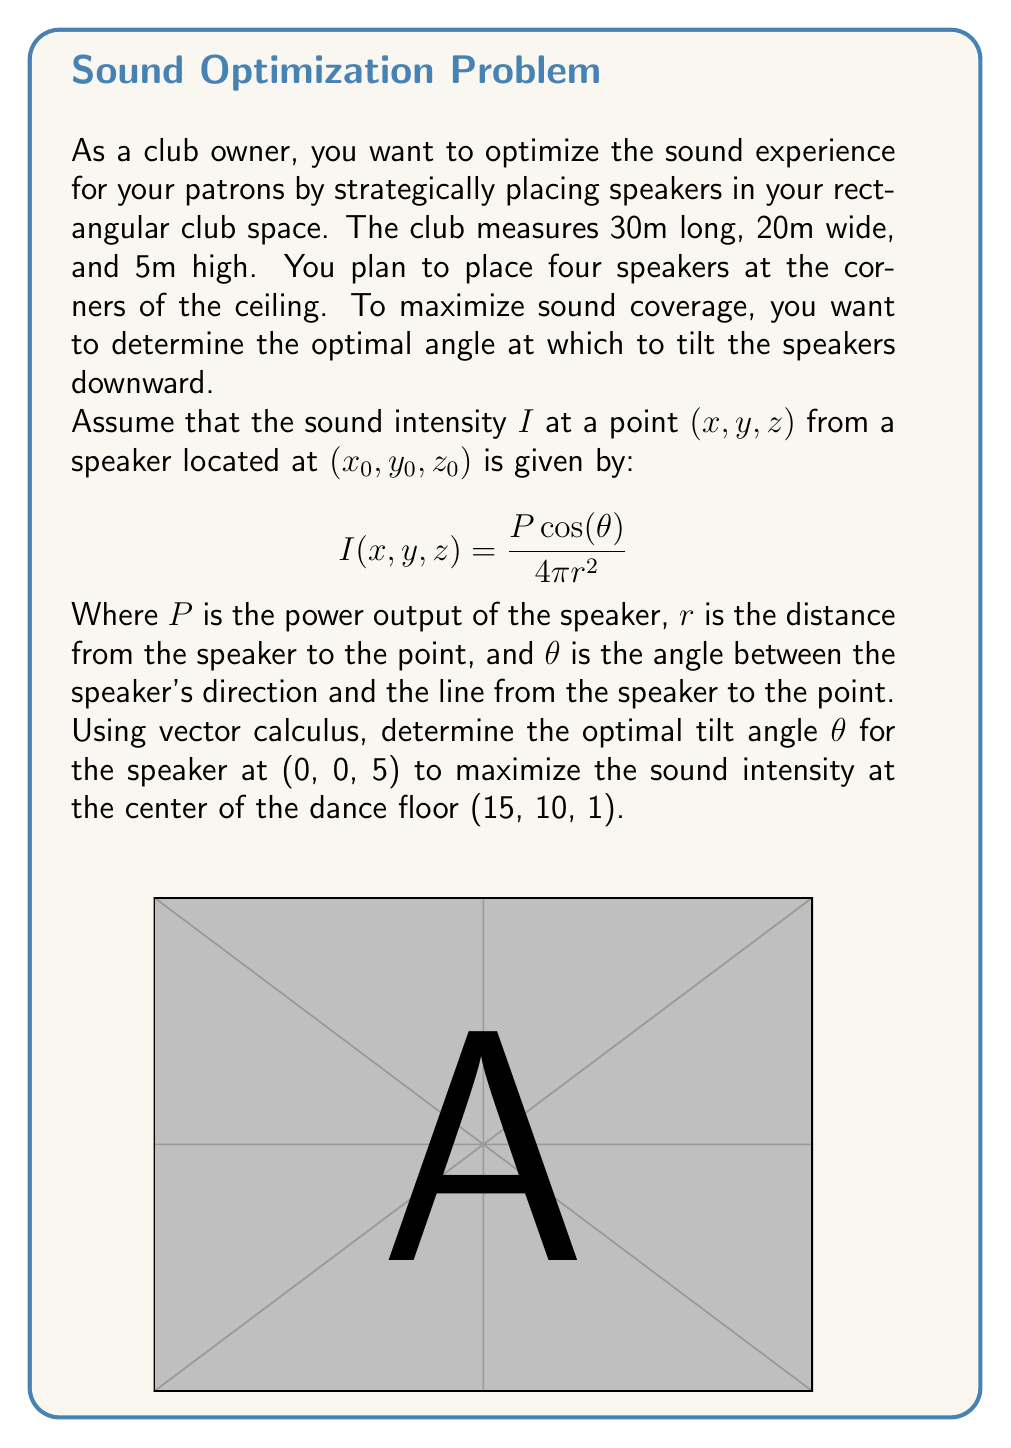Show me your answer to this math problem. Let's approach this step-by-step:

1) First, we need to find the vector from the speaker to the center of the dance floor:
   $\vec{v} = (15, 10, -4)$

2) The magnitude of this vector (distance $r$) is:
   $r = \sqrt{15^2 + 10^2 + (-4)^2} = \sqrt{425} \approx 20.616$ m

3) The unit vector in the direction of $\vec{v}$ is:
   $\hat{v} = (\frac{15}{\sqrt{425}}, \frac{10}{\sqrt{425}}, \frac{-4}{\sqrt{425}})$

4) The speaker's direction vector when tilted at an angle $\theta$ from the vertical is:
   $\vec{d} = (0, 0, -1)$ when $\theta = 0$, and $(sin\theta, 0, -cos\theta)$ in general.

5) The cosine of the angle between $\vec{d}$ and $\vec{v}$ is their dot product:
   $cos(\alpha) = \vec{d} \cdot \hat{v} = sin\theta \cdot \frac{15}{\sqrt{425}} + 0 \cdot \frac{10}{\sqrt{425}} + (-cos\theta) \cdot \frac{-4}{\sqrt{425}}$

6) Simplifying:
   $cos(\alpha) = \frac{15sin\theta + 4cos\theta}{\sqrt{425}}$

7) The intensity formula becomes:
   $I = \frac{P}{4\pi r^2} \cdot \frac{15sin\theta + 4cos\theta}{\sqrt{425}}$

8) To maximize this, we differentiate with respect to $\theta$ and set to zero:
   $\frac{dI}{d\theta} = \frac{P}{4\pi r^2 \sqrt{425}} (15cos\theta - 4sin\theta) = 0$

9) Solving this equation:
   $15cos\theta = 4sin\theta$
   $tan\theta = \frac{15}{4} = 3.75$

10) Taking the inverse tangent:
    $\theta = arctan(3.75) \approx 1.3108$ radians or about 75.1°
Answer: $75.1°$ 